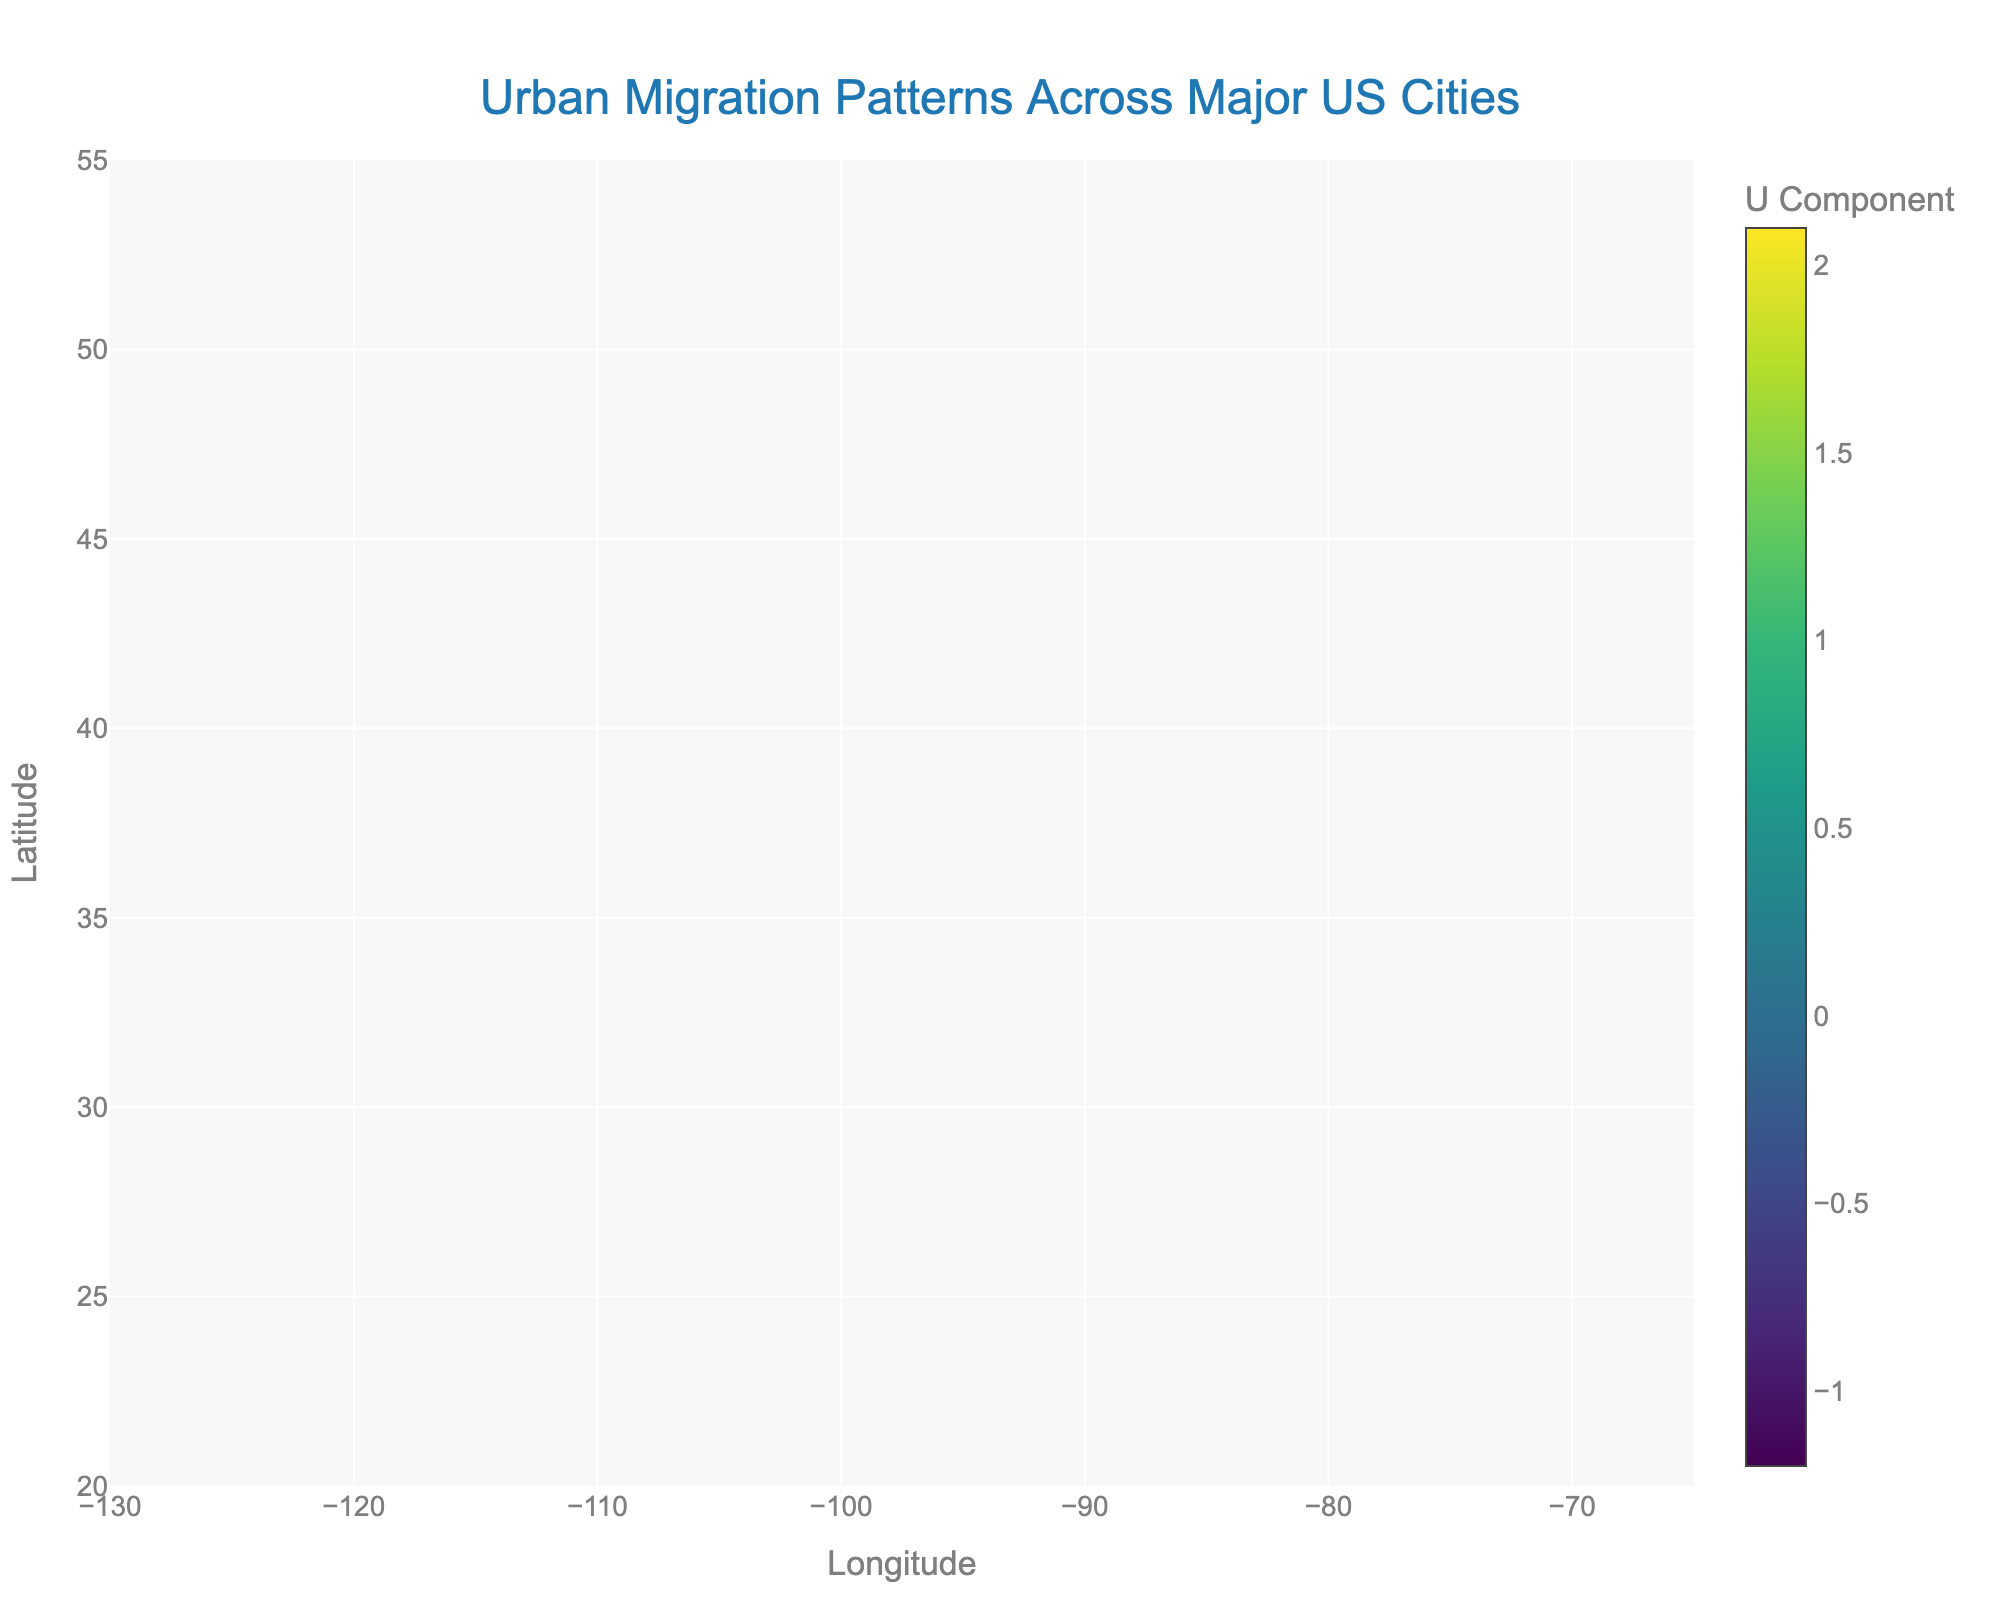What is the title of the plot? The title of the plot is displayed prominently at the top of the figure. It reads "Urban Migration Patterns Across Major US Cities".
Answer: Urban Migration Patterns Across Major US Cities How many major cities are represented in the plot? By counting the city labels in the figure, there are 12 cities represented.
Answer: 12 Which city shows the largest positive change in the Y-axis direction? The arrows in the plot indicate migration directions and magnitudes. Seattle's arrow (V = 2.2) shows the largest positive change in the Y-axis direction.
Answer: Seattle Which cities have a negative X-axis migration direction? Cities with arrows pointing to the left represent a negative X-axis direction. These cities are New York, Chicago, Philadelphia, Boston, San Francisco.
Answer: New York, Chicago, Philadelphia, Boston, San Francisco What city has the largest negative change in the Y-axis direction? Miami's arrow (V = -1.3) points downwards, which represents the largest negative change in the Y-axis direction.
Answer: Miami Compare the migration patterns of Los Angeles and Houston. Which city has a higher Y-axis change? Observing the arrow lengths and directions, Los Angeles has a Y-axis change of -0.7, while Houston has a Y-axis change of 0.9. Therefore, Houston has a higher Y-axis change.
Answer: Houston Which city is represented at the lowest latitude on the plot? On the Y-axis (latitude), the lowest city label is Miami.
Answer: Miami How does the migration pattern of New York compare to that of Washington D.C.? New York has an arrow with components U = -0.5 and V = 2.3, showing northwest migration. Washington D.C. has components U = 0.5 and V = 1.0, showing northeast migration.
Answer: New York shows northwest migration while Washington D.C. shows northeast migration Which city's arrow indicates migration predominantly in the X-axis direction? Houston's arrow has a large U component (2.1) and a smaller V component (0.9), indicating migration predominantly in the X-axis direction.
Answer: Houston What is the color scale used for the arrow colors, and what does it represent? The color scale used is "Viridis," and it represents the U component of the migration vectors.
Answer: Viridis (representing the U component) 